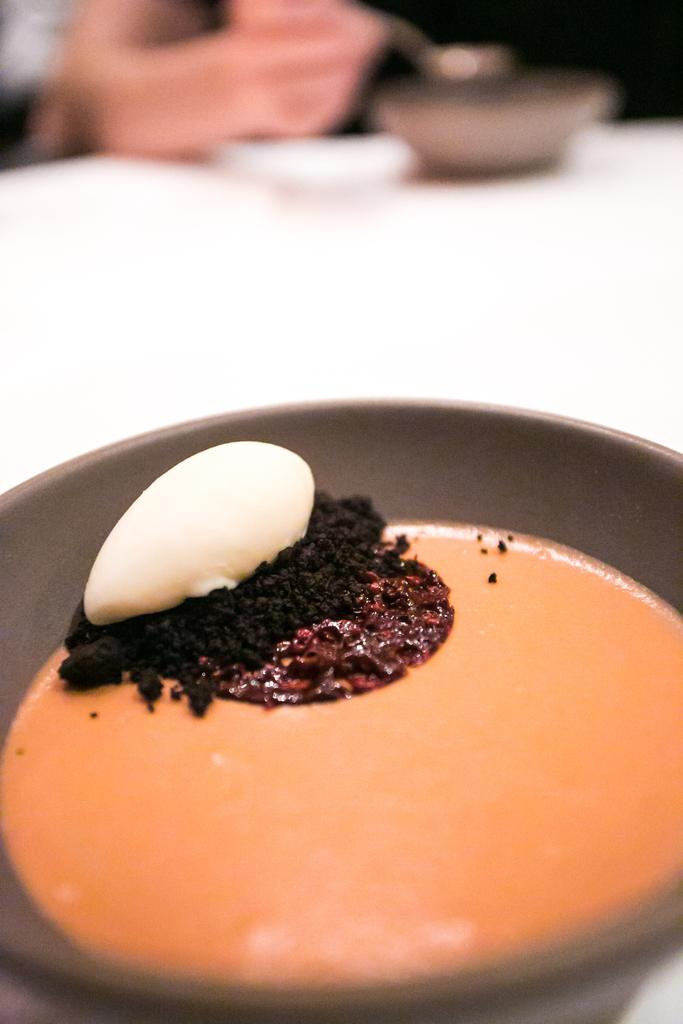What piece of furniture is present in the image? There is a table in the image. What is placed on the table? There is a bowl on the table. What is inside the bowl? There is a food item in the bowl. Can you describe the background of the image? The background of the image is blurred. How much money is being exchanged in the image? There is no money present in the image; it features a table, a bowl, and a food item. What month is depicted in the image? There is no indication of a specific month in the image; it only shows a table, a bowl, and a food item. 